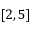Convert formula to latex. <formula><loc_0><loc_0><loc_500><loc_500>[ 2 , 5 ]</formula> 